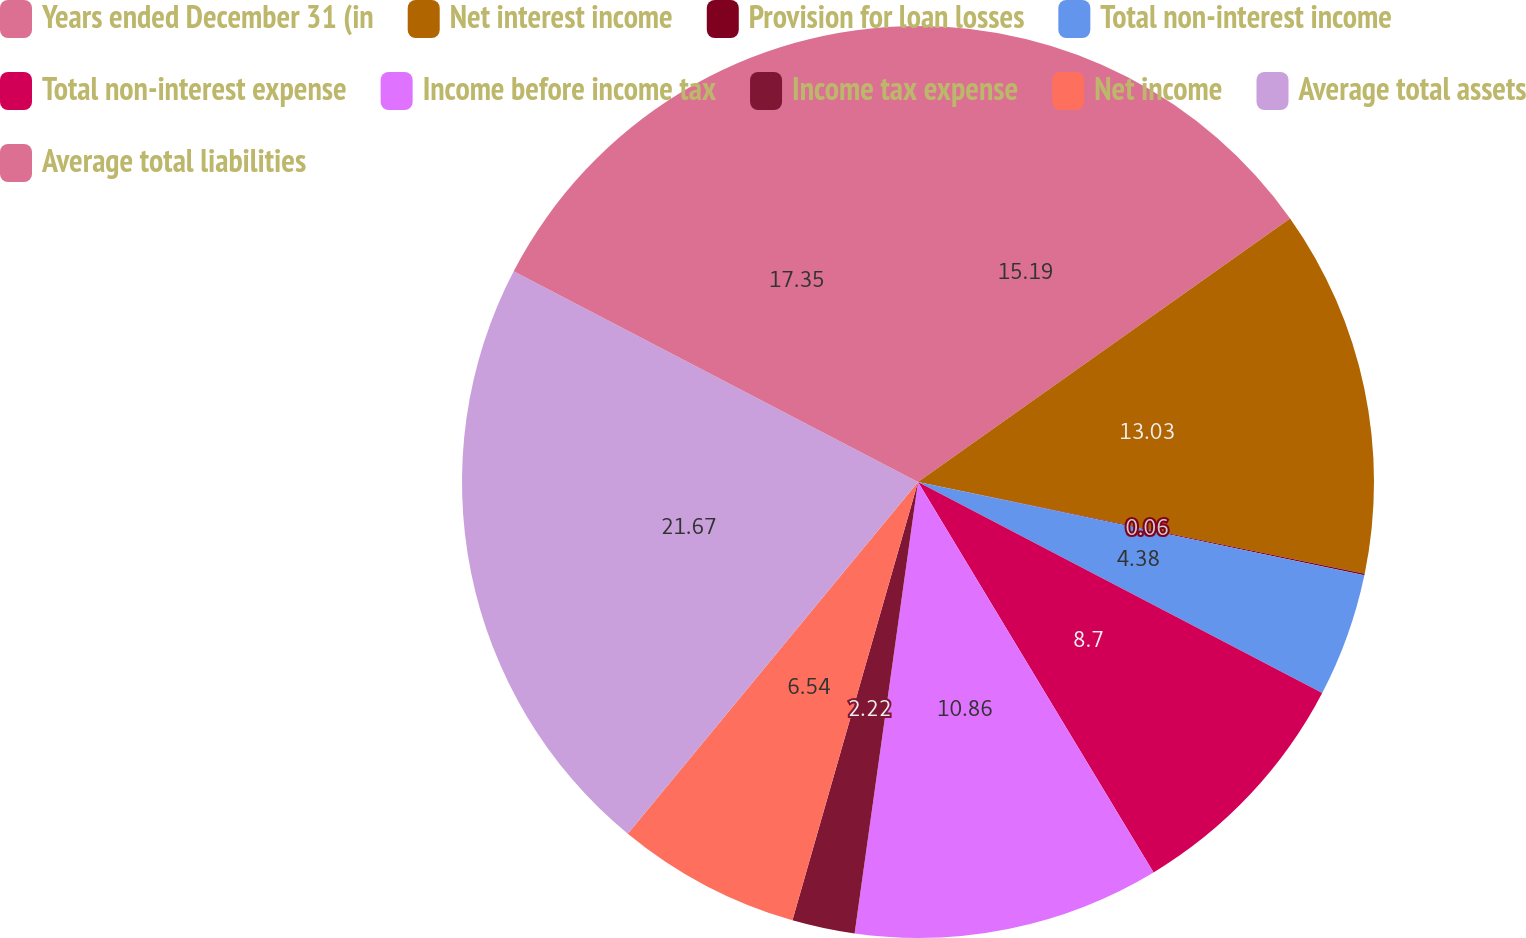Convert chart. <chart><loc_0><loc_0><loc_500><loc_500><pie_chart><fcel>Years ended December 31 (in<fcel>Net interest income<fcel>Provision for loan losses<fcel>Total non-interest income<fcel>Total non-interest expense<fcel>Income before income tax<fcel>Income tax expense<fcel>Net income<fcel>Average total assets<fcel>Average total liabilities<nl><fcel>15.19%<fcel>13.03%<fcel>0.06%<fcel>4.38%<fcel>8.7%<fcel>10.86%<fcel>2.22%<fcel>6.54%<fcel>21.67%<fcel>17.35%<nl></chart> 